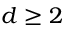Convert formula to latex. <formula><loc_0><loc_0><loc_500><loc_500>d \geq 2</formula> 